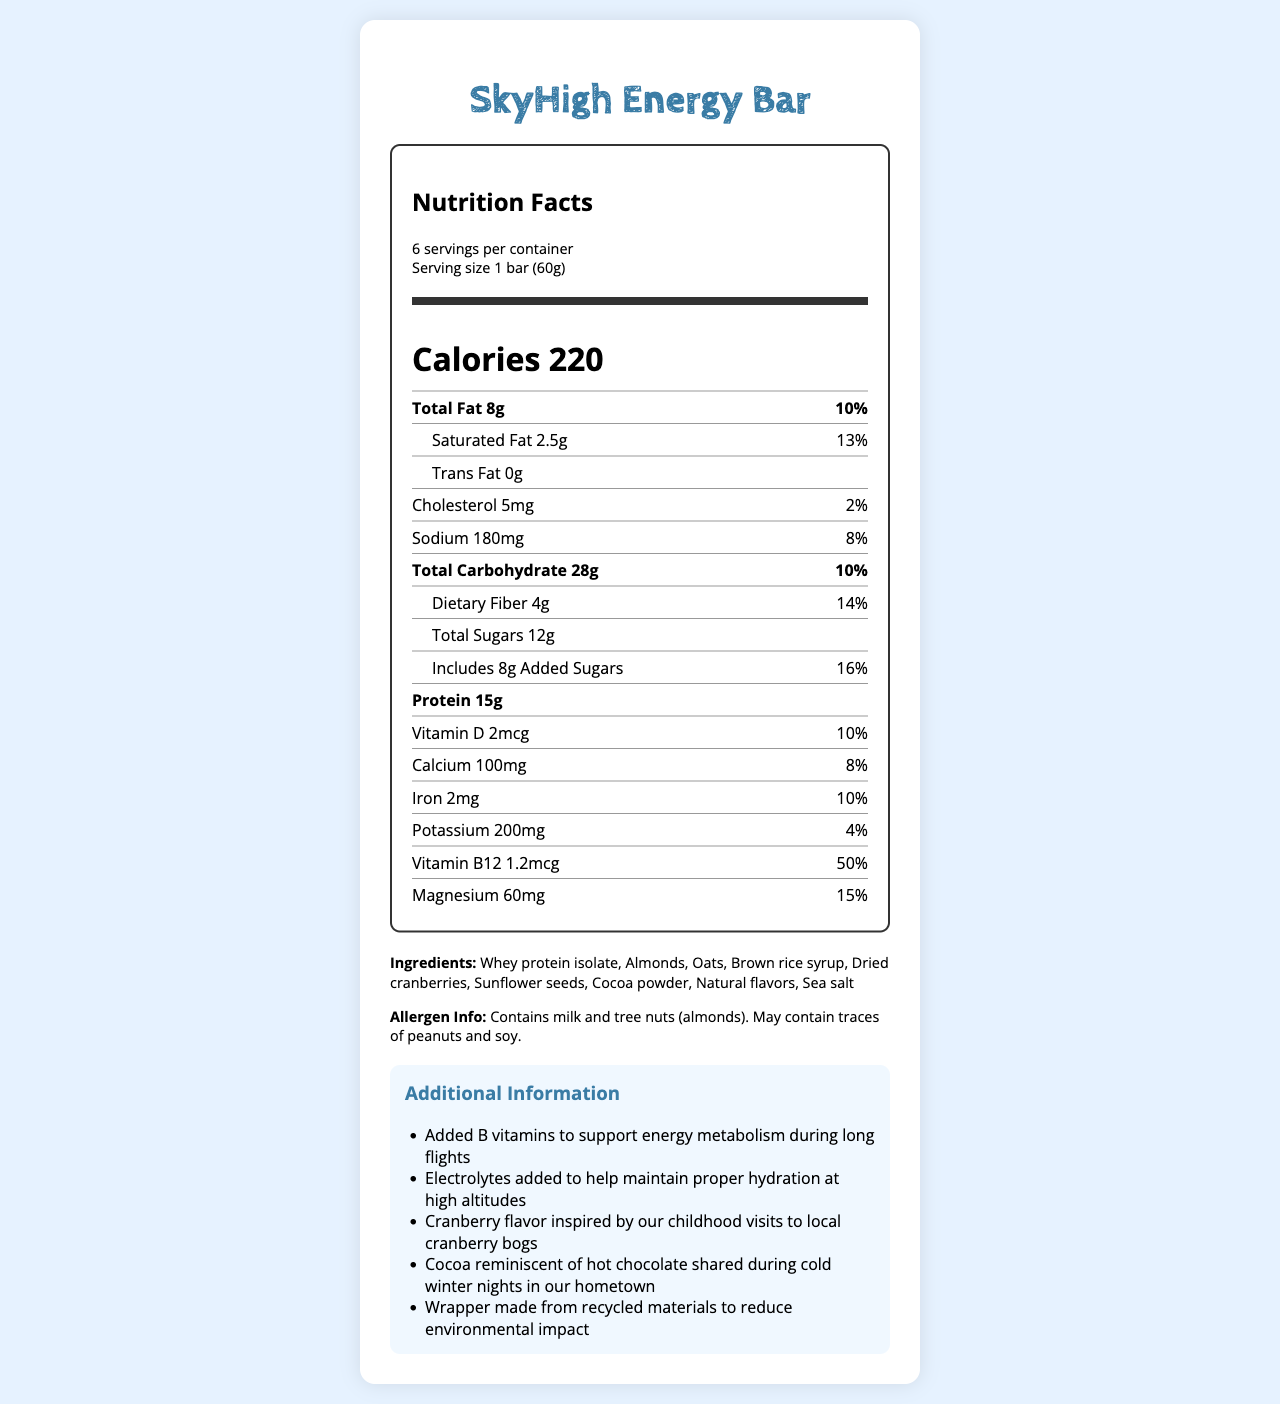who manufactures the SkyHigh Energy Bar? The document does not mention the manufacturer of the SkyHigh Energy Bar.
Answer: Cannot be determined how many servings are there per container? The document states that there are 6 servings per container.
Answer: 6 servings what is the serving size of the SkyHigh Energy Bar? The document indicates that the serving size is 1 bar (60g).
Answer: 1 bar (60g) how many calories are there per serving? The document lists the calorie content as 220 calories per serving.
Answer: 220 calories what is the total fat content per serving? The document shows that the total fat content per serving is 8g.
Answer: 8g what is the daily value percentage of saturated fat? The document states that the daily value percentage for saturated fat is 13%.
Answer: 13% does the SkyHigh Energy Bar contain trans fat? The document specifies that the trans fat content is 0g.
Answer: No what is the sodium content in one serving? The document states that the sodium content per serving is 180mg.
Answer: 180mg what are the added sugars in the SkyHigh Energy Bar? A. 6g B. 8g C. 10g D. 12g The document shows that the added sugars amount to 8g.
Answer: B how much protein does one SkyHigh Energy Bar provide? A. 10g B. 12g C. 15g D. 18g The document indicates that each bar contains 15g of protein.
Answer: C does the SkyHigh Energy Bar contain peanuts? The allergen info states that the bar may contain traces of peanuts.
Answer: May contain traces how many ingredients are listed in the SkyHigh Energy Bar? The document lists a total of 9 ingredients.
Answer: 9 ingredients what additional information is available about the SkyHigh Energy Bar? The document provides details under "Additional Information" about the added B vitamins for jet lag support, electrolytes for hydration, cranberry flavor inspired by hometown, cocoa for nostalgia, and sustainable packaging.
Answer: It offers jet lag support, hydration boost, is inspired by hometown cranberry flavor, cocoa for nostalgia, and uses sustainable packaging. is the wrapper of the SkyHigh Energy Bar made from recycled materials? The additional information section mentions that the wrapper is made from recycled materials.
Answer: Yes what is the main source of protein in the SkyHigh Energy Bar? The document lists whey protein isolate as the first ingredient, indicating it is the primary source of protein.
Answer: Whey protein isolate summarize the main nutritional attributes and unique features of the SkyHigh Energy Bar. The document describes the bar's nutritional content, including calories, fats, sugars, and vitamins. It highlights additional features like B vitamins for energy, electrolytes for hydration, and sustainable packaging, as well as nostalgic elements from the creators' hometown.
Answer: The SkyHigh Energy Bar provides 220 calories, 8g total fat, 15g protein, and various vitamins and minerals. It supports jet lag recovery, hydration, and uses sustainable packaging, with nostalgic flavors inspired by childhood memories. 